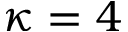<formula> <loc_0><loc_0><loc_500><loc_500>\kappa = 4</formula> 